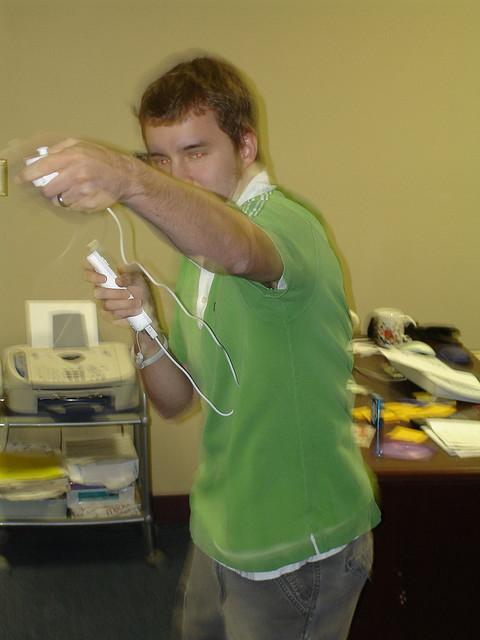What office equipment is on the shelf? printer 